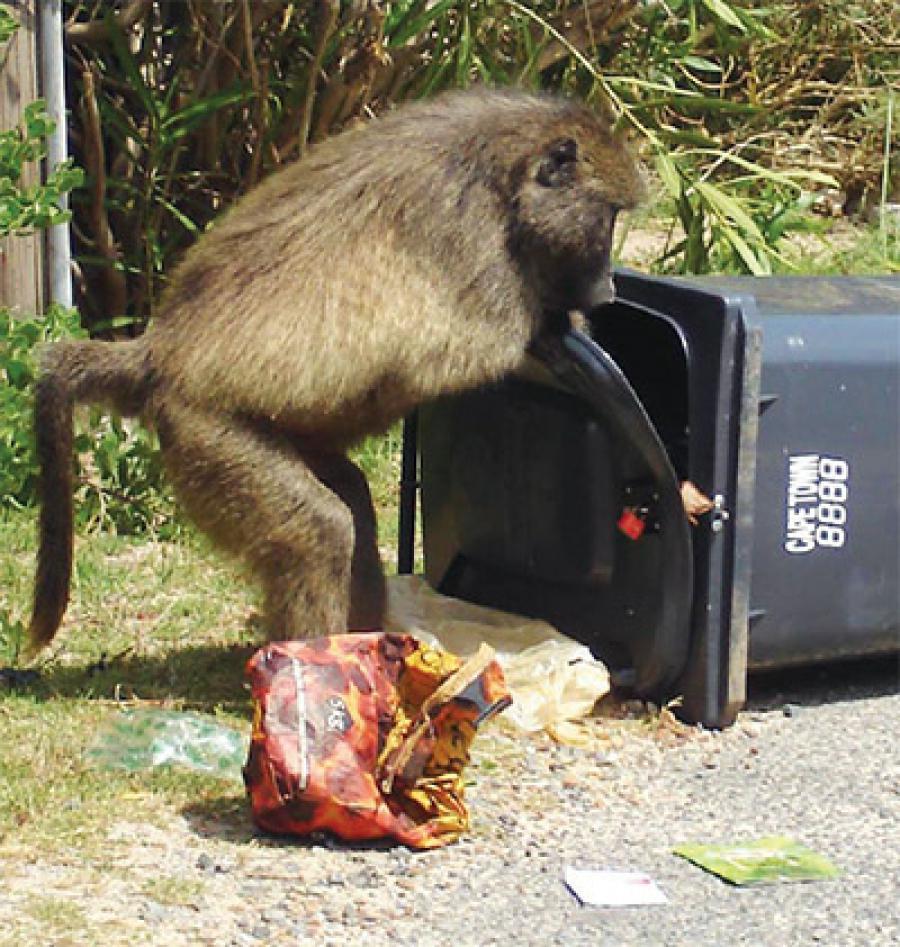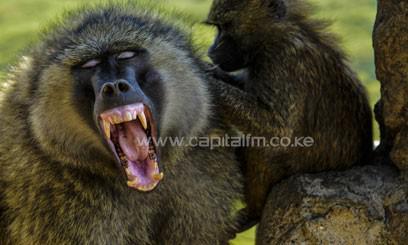The first image is the image on the left, the second image is the image on the right. Examine the images to the left and right. Is the description "One image shows the face of a fang-baring baboon in profile, and the other image includes a baby baboon." accurate? Answer yes or no. No. The first image is the image on the left, the second image is the image on the right. Evaluate the accuracy of this statement regarding the images: "In one image there is an adult monkey holding onto food with a young monkey nearby.". Is it true? Answer yes or no. No. 